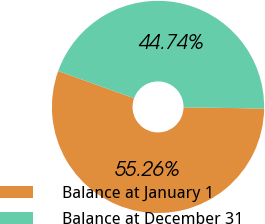<chart> <loc_0><loc_0><loc_500><loc_500><pie_chart><fcel>Balance at January 1<fcel>Balance at December 31<nl><fcel>55.26%<fcel>44.74%<nl></chart> 